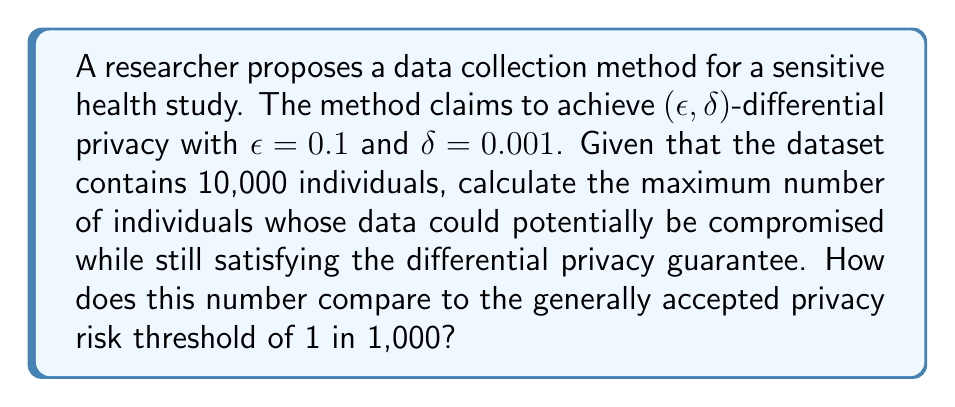Can you answer this question? To solve this problem, we'll follow these steps:

1) In $(\epsilon, \delta)$-differential privacy, $\delta$ represents the probability that the privacy guarantee might not hold. In other words, it's the maximum probability of a privacy breach.

2) Given $\delta = 0.001$, this means that for any individual in the dataset, there's at most a 0.1% chance that their privacy could be compromised.

3) To find the maximum number of individuals whose data could be compromised, we multiply the total number of individuals by $\delta$:

   $$10,000 \times 0.001 = 10$$

4) This means that, in the worst-case scenario, the data of up to 10 individuals could potentially be compromised while still satisfying the differential privacy guarantee.

5) To compare this to the generally accepted privacy risk threshold of 1 in 1,000:
   - The given method results in a risk of 10 in 10,000, which simplifies to 1 in 1,000.
   - This is exactly equal to the generally accepted threshold.

6) While the risk meets the general threshold, it's worth noting that the $\epsilon$ value of 0.1 is relatively low, indicating a strong privacy guarantee for the data that is protected.
Answer: 10 individuals; meets the 1 in 1,000 threshold 